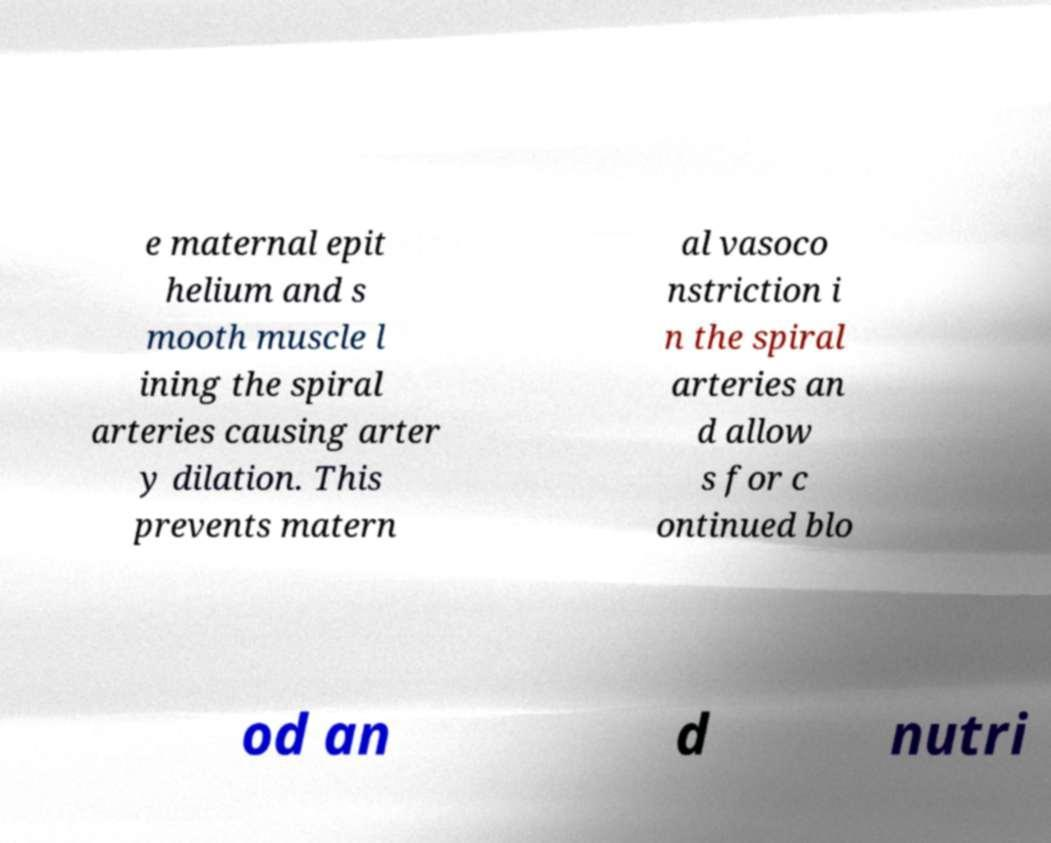I need the written content from this picture converted into text. Can you do that? e maternal epit helium and s mooth muscle l ining the spiral arteries causing arter y dilation. This prevents matern al vasoco nstriction i n the spiral arteries an d allow s for c ontinued blo od an d nutri 